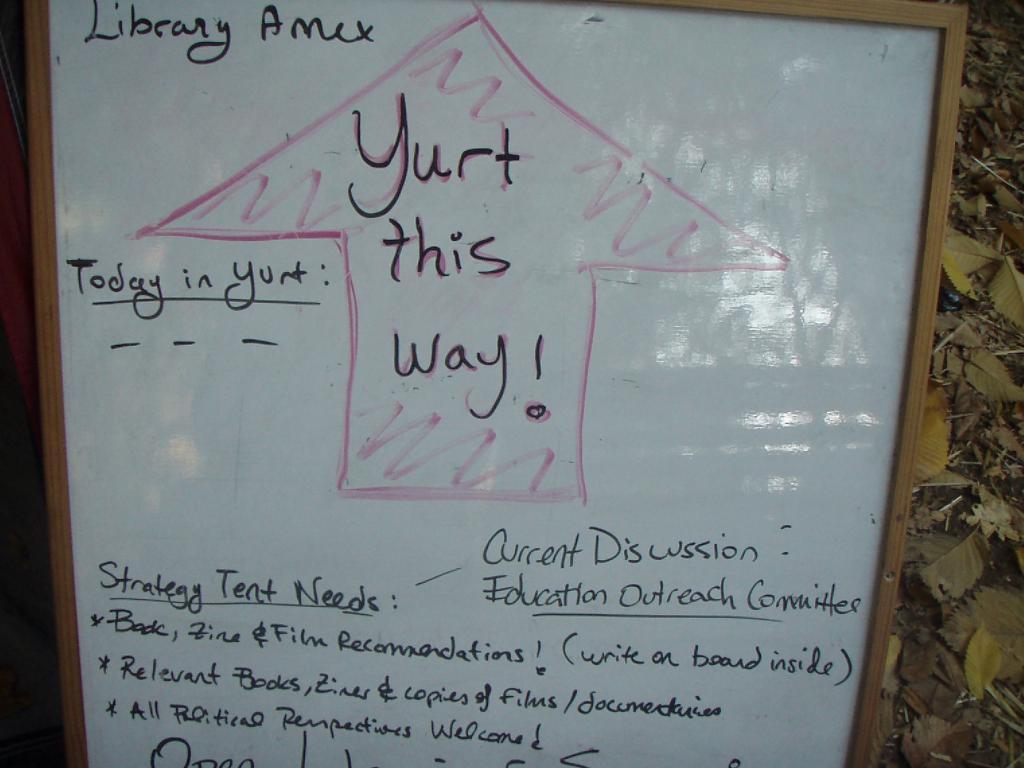Can you describe this image briefly? In the foreground of this image, there is a white board on which, there is text. In the background, there are leaves on the ground. 